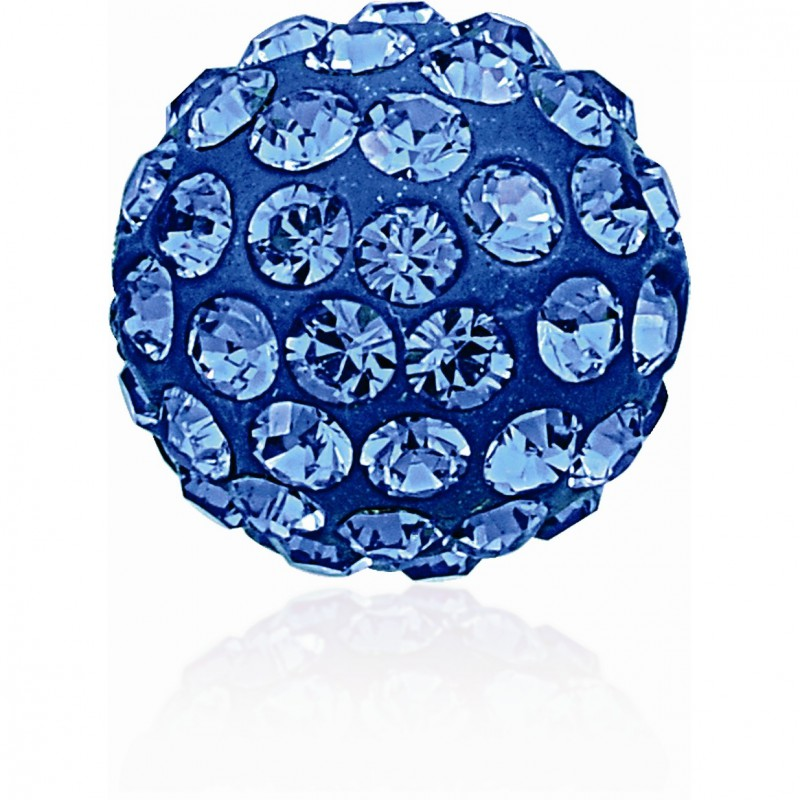How does the color of the gemstones affect the overall design? The color of the gemstones plays a crucial role in the overall design. In this case, the deep blue hue of the gemstones not only creates a sense of elegance and luxury but also evokes feelings of tranquility and depth. The consistency in color unifies the design, making it visually cohesive, while the blue tone can enhance the perception of depth, making the piece appear even more intricate. Additionally, the color affects how light interacts with the gemstones, with darker stones often providing a dramatic interplay of light and shadow, adding to the visual interest. Can you imagine a scenario where someone might wear this piece? Certainly! Imagine a grand gala event at a luxurious ballroom, where everything is adorned with crystal chandeliers and opulent decorations. A person wearing a sophisticated, floor-length evening gown steps into the room. She wears this exquisite, blue gemstone-studded accessory as a brooch, pinned just below her left shoulder. As she moves and mingles with the other guests, the twinkling lights from the chandeliers catch the gemstones, causing them to sparkle brilliantly. The blue gemstones complement her dress perfectly, adding a touch of regal elegance to her ensemble and making her the center of attention in the room. 